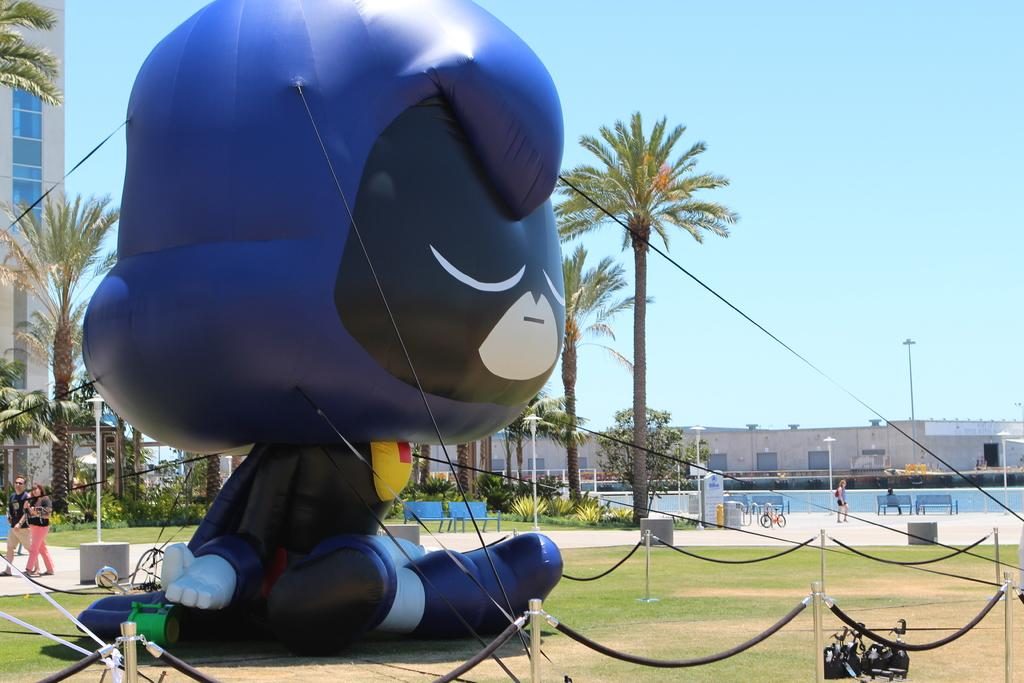What type of inflatable object is in the image? The image contains an inflatable object, but the specific type is not mentioned. What is the fence made of in the image? The facts do not specify the material of the fence. What is the rope used for in the image? The purpose of the rope in the image is not mentioned. What type of trees are in the image? The facts do not specify the type of trees. What are the people doing in the image? The facts do not describe the actions of the people. What type of bicycle is in the image? The image contains a bicycle, but the specific type is not mentioned. What type of plants are in the image? The facts do not specify the type of plants. Can you see any celery growing in the image? There is no celery present in the image. Is there a sheet covering the inflatable object in the image? The facts do not mention a sheet in the image. How many frogs can be seen interacting with the people in the image? There are no frogs present in the image. 